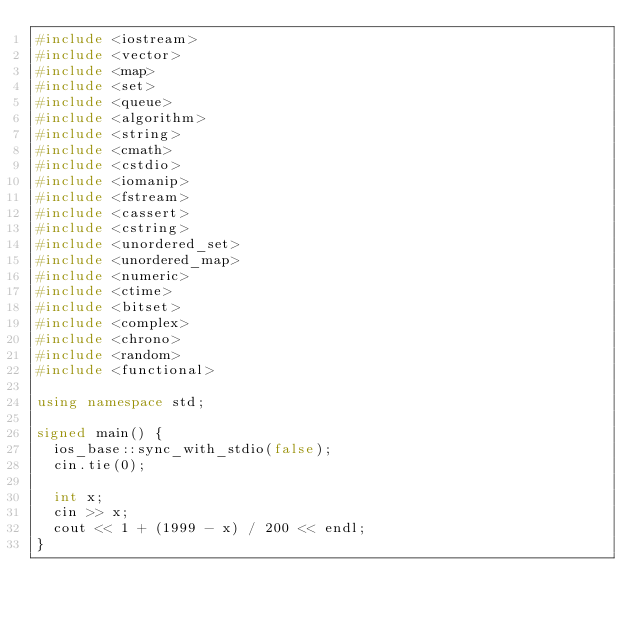<code> <loc_0><loc_0><loc_500><loc_500><_C++_>#include <iostream>
#include <vector>
#include <map>
#include <set>
#include <queue>
#include <algorithm>
#include <string>
#include <cmath>
#include <cstdio>
#include <iomanip>
#include <fstream>
#include <cassert>
#include <cstring>
#include <unordered_set>
#include <unordered_map>
#include <numeric>
#include <ctime>
#include <bitset>
#include <complex>
#include <chrono>
#include <random>
#include <functional>

using namespace std;

signed main() {
	ios_base::sync_with_stdio(false);
	cin.tie(0);

	int x;
	cin >> x;
	cout << 1 + (1999 - x) / 200 << endl;
}</code> 